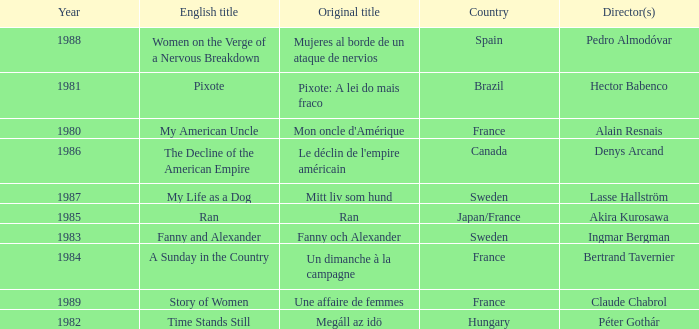Write the full table. {'header': ['Year', 'English title', 'Original title', 'Country', 'Director(s)'], 'rows': [['1988', 'Women on the Verge of a Nervous Breakdown', 'Mujeres al borde de un ataque de nervios', 'Spain', 'Pedro Almodóvar'], ['1981', 'Pixote', 'Pixote: A lei do mais fraco', 'Brazil', 'Hector Babenco'], ['1980', 'My American Uncle', "Mon oncle d'Amérique", 'France', 'Alain Resnais'], ['1986', 'The Decline of the American Empire', "Le déclin de l'empire américain", 'Canada', 'Denys Arcand'], ['1987', 'My Life as a Dog', 'Mitt liv som hund', 'Sweden', 'Lasse Hallström'], ['1985', 'Ran', 'Ran', 'Japan/France', 'Akira Kurosawa'], ['1983', 'Fanny and Alexander', 'Fanny och Alexander', 'Sweden', 'Ingmar Bergman'], ['1984', 'A Sunday in the Country', 'Un dimanche à la campagne', 'France', 'Bertrand Tavernier'], ['1989', 'Story of Women', 'Une affaire de femmes', 'France', 'Claude Chabrol'], ['1982', 'Time Stands Still', 'Megáll az idö', 'Hungary', 'Péter Gothár']]} What was the original title that was directed by Alain Resnais in France before 1986? Mon oncle d'Amérique. 